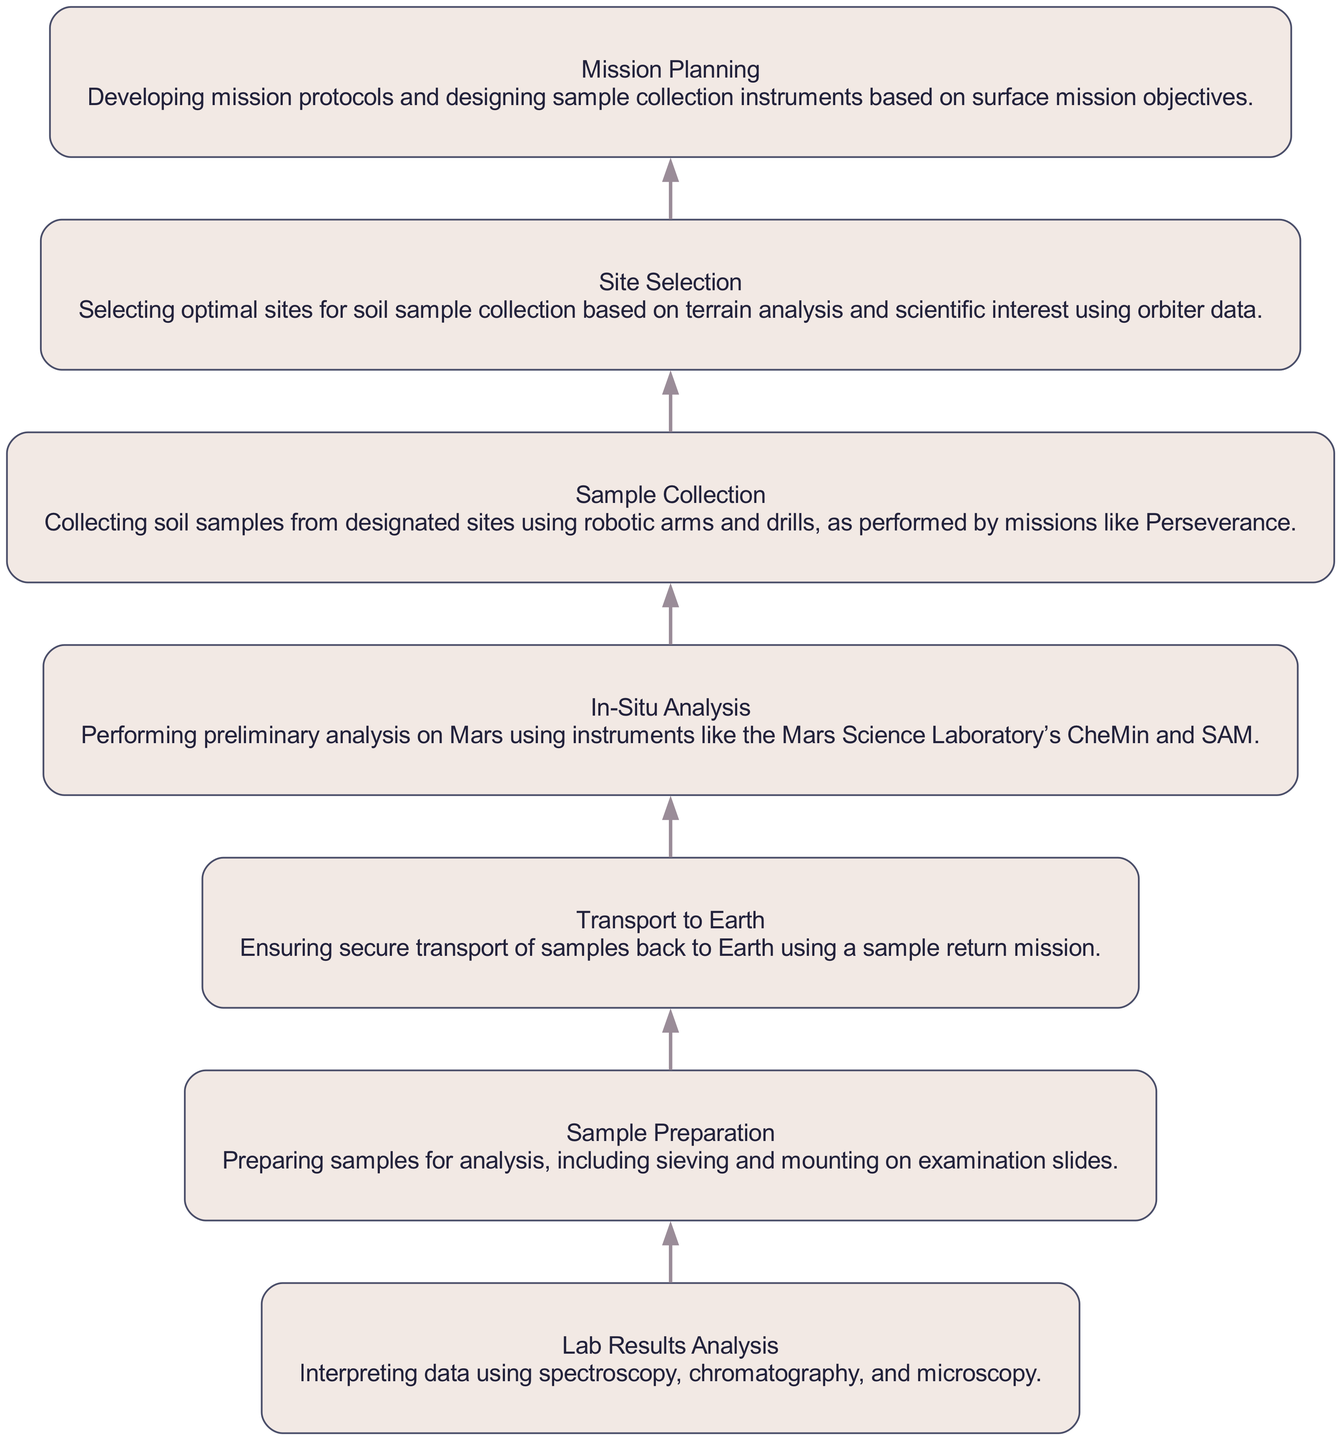What is the first stage in the diagram? The first stage in the diagram, which is the bottom-most node, is "Mission Planning." This represents the initial step in the process of analyzing Martian soil samples.
Answer: Mission Planning How many stages are there in total? By counting all the stages represented in the diagram, we find there are a total of seven stages. Each stage is connected, showing the flow of the process from top to bottom.
Answer: Seven What follows "In-Situ Analysis" in the flow? After "In-Situ Analysis," the next stage in the flow is "Sample Preparation." This shows the sequence of activities after preliminary analysis has been conducted on Mars.
Answer: Sample Preparation What is the purpose of the "Site Selection" stage? The purpose of the "Site Selection" stage is to determine optimal locations for soil sample collection based on scientific interest and terrain analysis, which is informed by orbiter data.
Answer: Selecting optimal sites Which stage involves analysis on Mars? The stage that involves analysis conducted on Mars is "In-Situ Analysis." This highlights that some preliminary work is done on-site before samples are sent to Earth.
Answer: In-Situ Analysis What happens after "Sample Collection"? The action that follows "Sample Collection" is "Transport to Earth," which indicates that collected samples must be securely sent back for further analysis.
Answer: Transport to Earth Which technique is mentioned for analyzing the lab results? The techniques mentioned for interpreting the lab results include spectroscopy, chromatography, and microscopy. All of these are analytical methods employed to study the properties of the Martian soil samples.
Answer: Spectroscopy, chromatography, microscopy Explain the relationship between "Sample Preparation" and "Lab Results Analysis." "Sample Preparation" leads into "Lab Results Analysis." This indicates that once samples are prepared—such as sieving and mounting for examination—they can then be analyzed in the lab for various scientific insights.
Answer: Sample Preparation leads to Lab Results Analysis What is the main goal of the flowchart? The main goal of the flowchart is to outline the entire process from the planning of the mission to analyzing the Martian soil samples in the laboratory, illustrating the progression of activities in space exploration research.
Answer: Analyzing Martian soil samples 